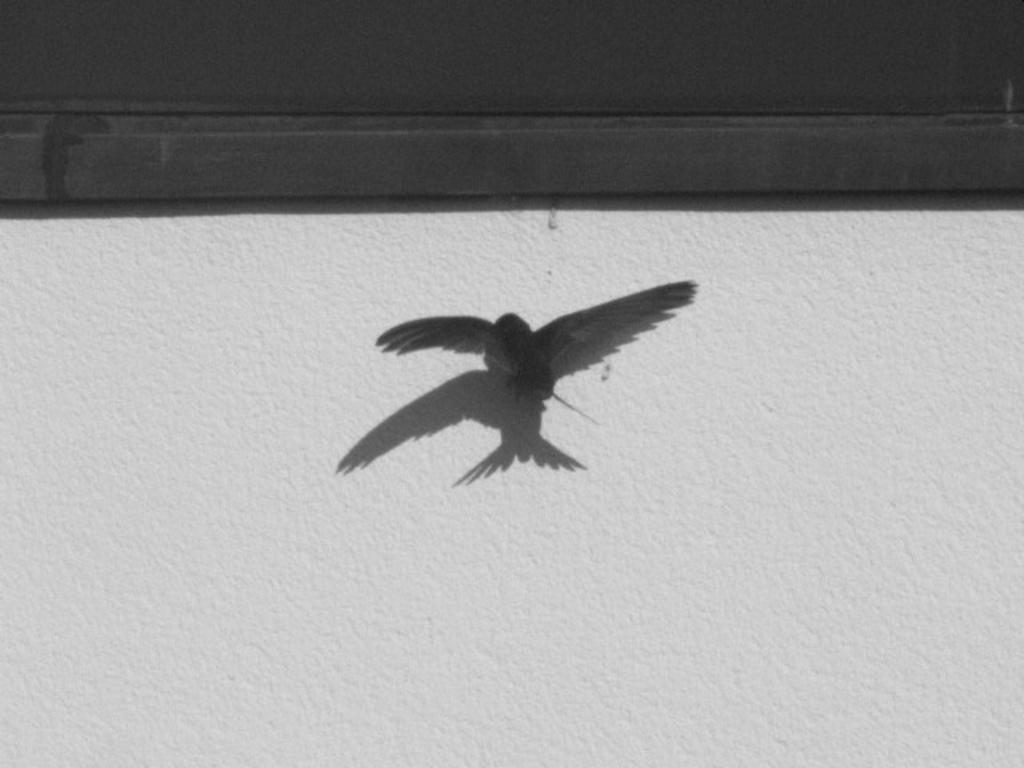What is the main subject of the image? There is a bird flying in the image. What can be seen in the background of the image? There is a wall and a black color object in the background of the image. What type of work is the bird doing in the image? The bird is not doing any work in the image; it is simply flying. Can you tell me the brand of the calculator visible in the image? There is no calculator present in the image. 